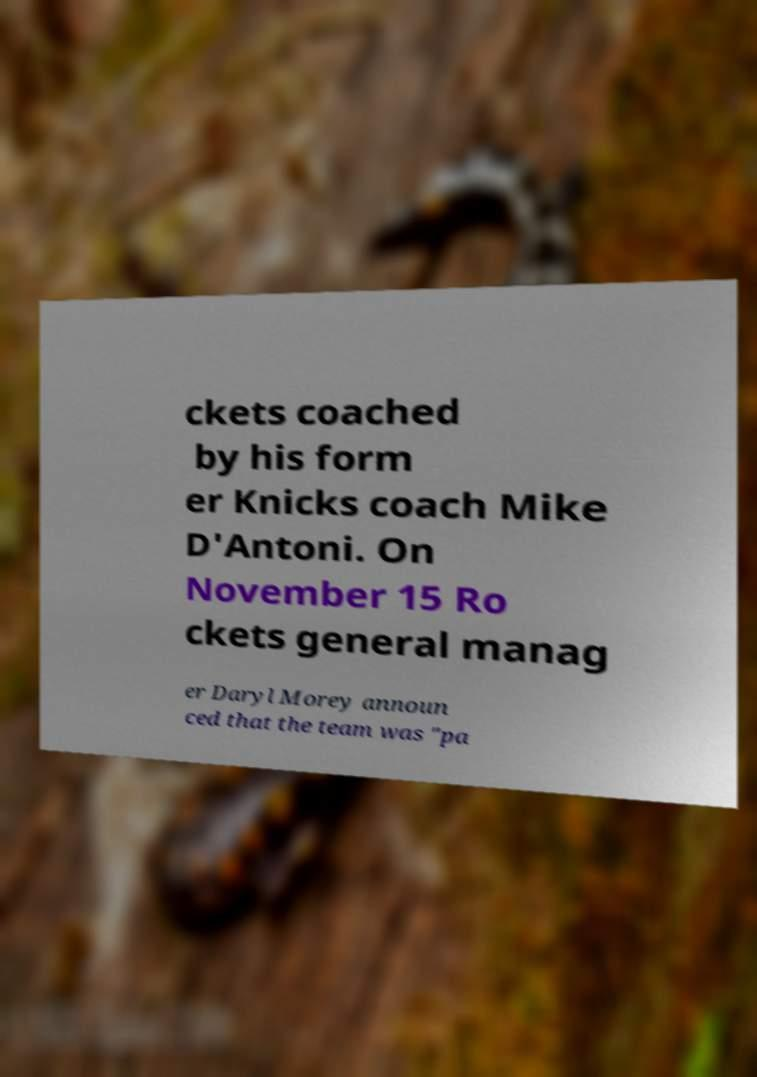What messages or text are displayed in this image? I need them in a readable, typed format. ckets coached by his form er Knicks coach Mike D'Antoni. On November 15 Ro ckets general manag er Daryl Morey announ ced that the team was "pa 